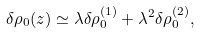<formula> <loc_0><loc_0><loc_500><loc_500>\delta \rho _ { 0 } ( z ) \simeq \lambda \delta \rho _ { 0 } ^ { ( 1 ) } + \lambda ^ { 2 } \delta \rho _ { 0 } ^ { ( 2 ) } ,</formula> 